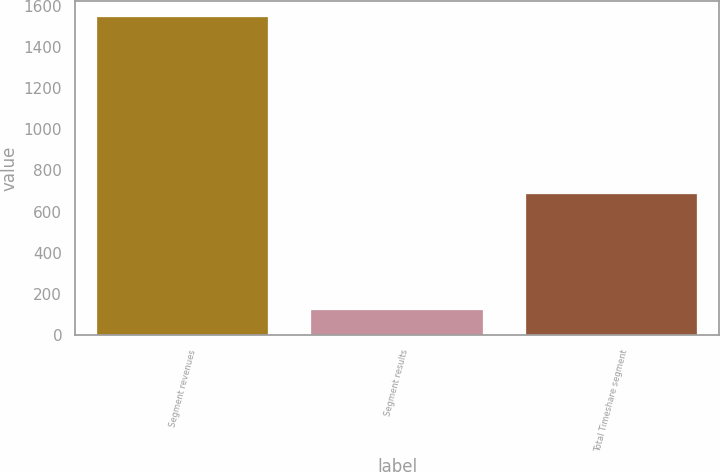Convert chart. <chart><loc_0><loc_0><loc_500><loc_500><bar_chart><fcel>Segment revenues<fcel>Segment results<fcel>Total Timeshare segment<nl><fcel>1546<fcel>121<fcel>685<nl></chart> 